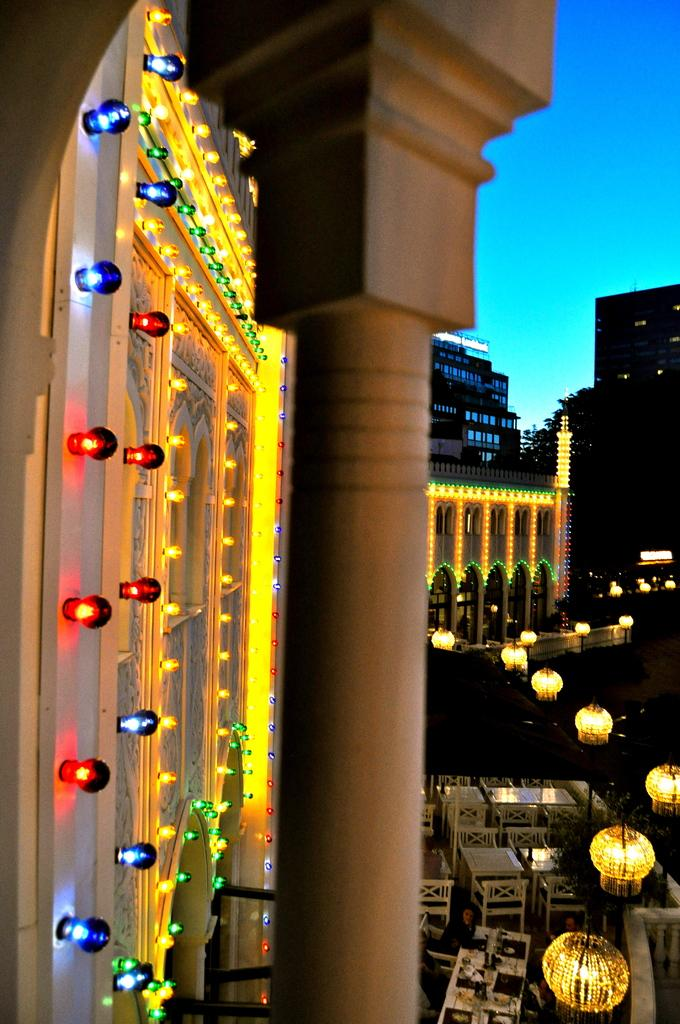What type of structures can be seen in the background of the image? There are buildings in the background of the image. What is located on the left side of the image? There is a wall with lights on the left side of the image. What can be found in the center of the image? There is a pillar in the center of the image. What type of furniture is visible in the image? There is no furniture present in the image. Can you see a train in the background of the image? There is no train visible in the image; only buildings are present in the background. 